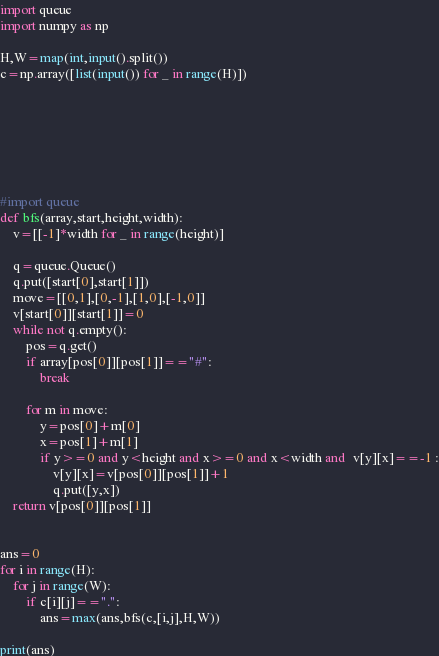<code> <loc_0><loc_0><loc_500><loc_500><_Python_>
import queue
import numpy as np

H,W=map(int,input().split())
c=np.array([list(input()) for _ in range(H)])







#import queue
def bfs(array,start,height,width):
    v=[[-1]*width for _ in range(height)]

    q=queue.Queue()
    q.put([start[0],start[1]])
    move=[[0,1],[0,-1],[1,0],[-1,0]]
    v[start[0]][start[1]]=0
    while not q.empty():
        pos=q.get()
        if array[pos[0]][pos[1]]=="#":          
            break
        
        for m in move:
            y=pos[0]+m[0]
            x=pos[1]+m[1]
            if y>=0 and y<height and x>=0 and x<width and  v[y][x]==-1 :
                v[y][x]=v[pos[0]][pos[1]]+1
                q.put([y,x])
    return v[pos[0]][pos[1]]


ans=0
for i in range(H):
    for j in range(W):
        if c[i][j]==".":
            ans=max(ans,bfs(c,[i,j],H,W))

print(ans)</code> 